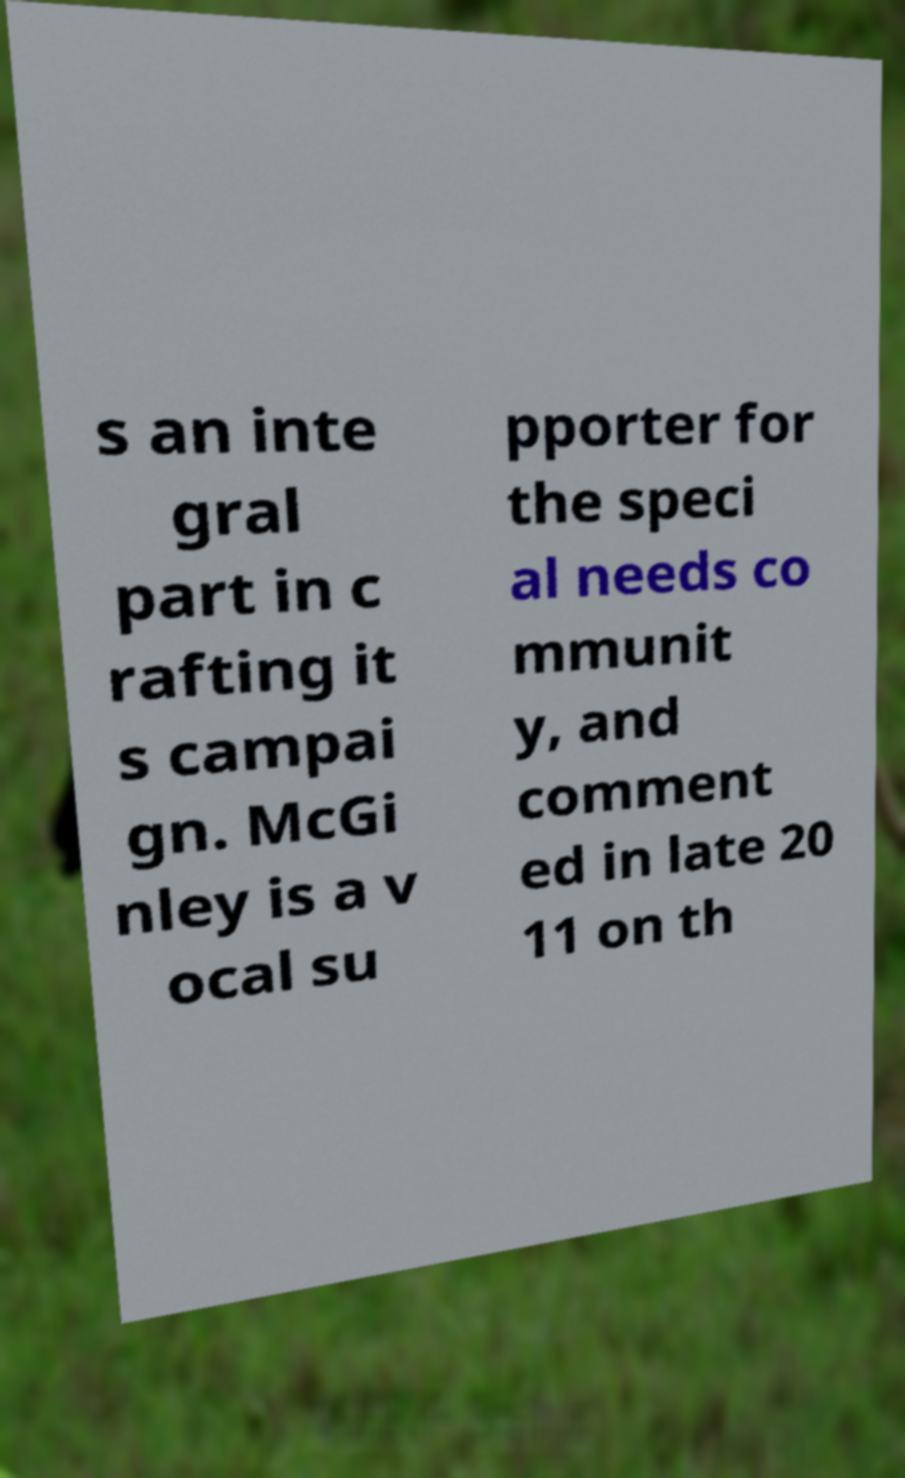Can you accurately transcribe the text from the provided image for me? s an inte gral part in c rafting it s campai gn. McGi nley is a v ocal su pporter for the speci al needs co mmunit y, and comment ed in late 20 11 on th 